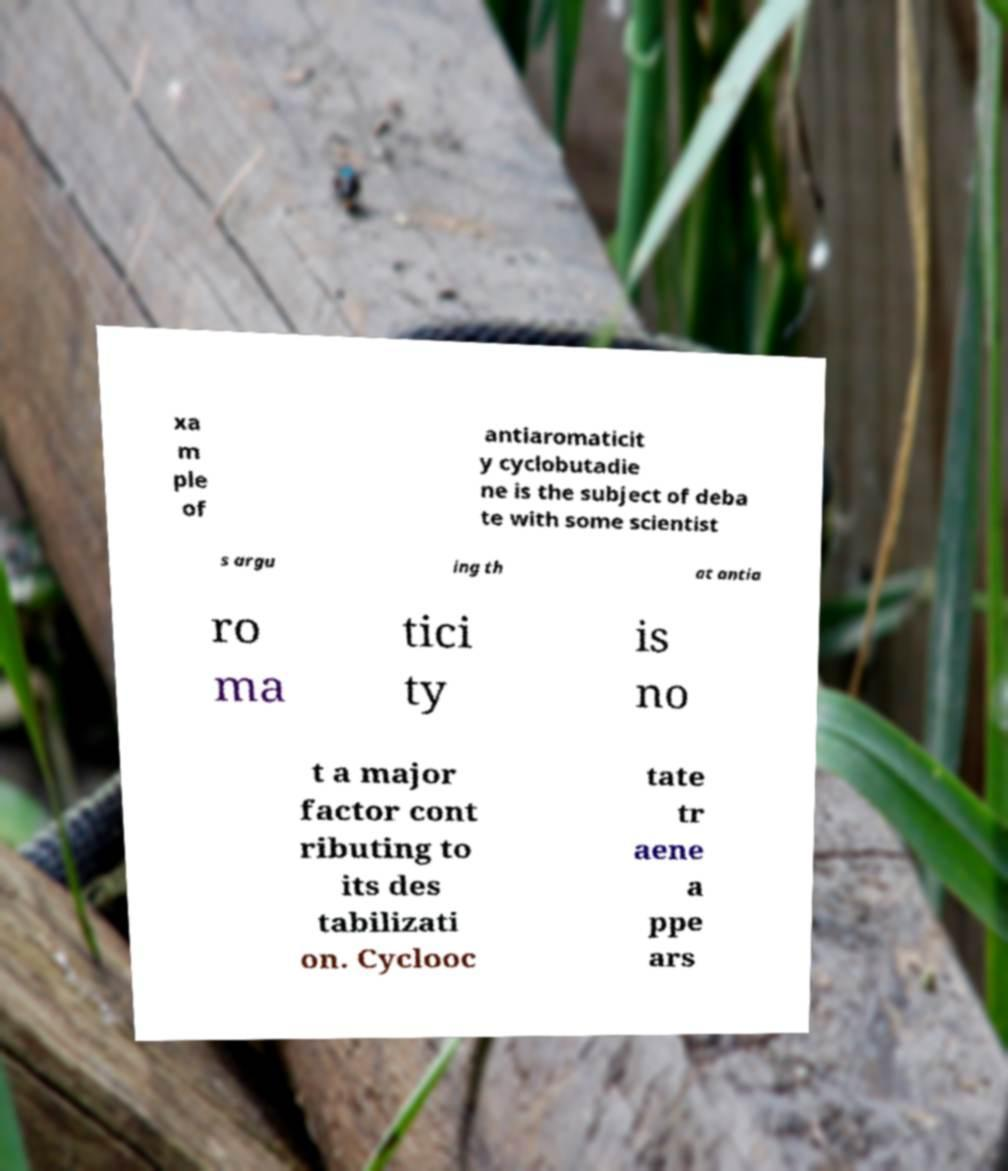Could you assist in decoding the text presented in this image and type it out clearly? xa m ple of antiaromaticit y cyclobutadie ne is the subject of deba te with some scientist s argu ing th at antia ro ma tici ty is no t a major factor cont ributing to its des tabilizati on. Cyclooc tate tr aene a ppe ars 